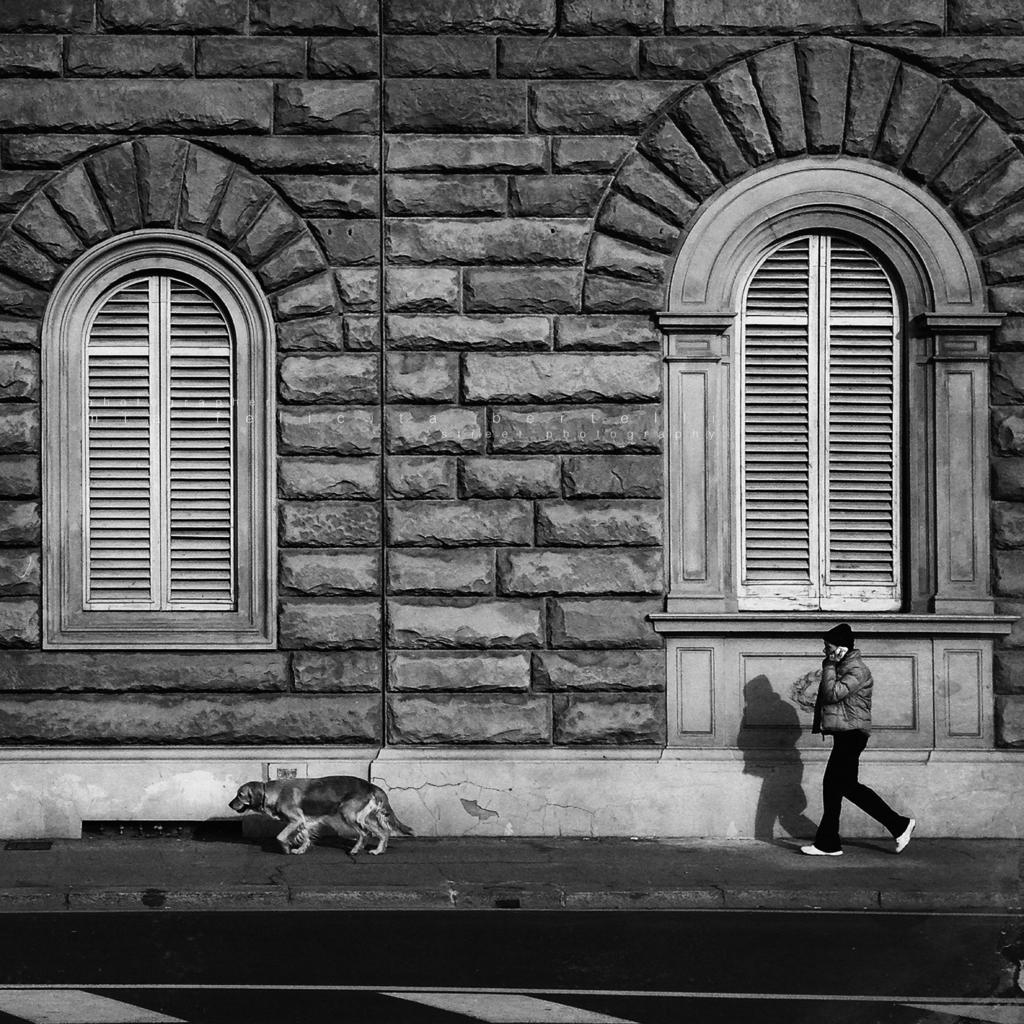Describe this image in one or two sentences. In this image, we can see a man walking and there is a dog running, there is a wall and there are two white color windows. 